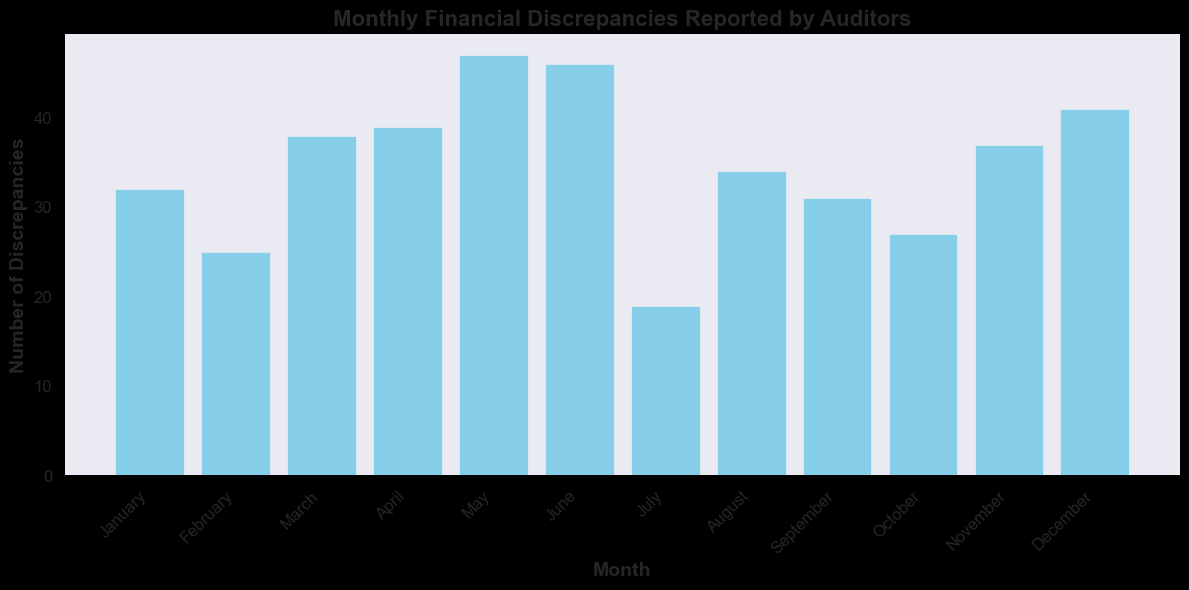What's the total number of discrepancies reported in March and April combined? First, find the number of discrepancies for March and April in the bar chart. For March, it's 38, and for April, it's 39. The total is 38 + 39 = 77.
Answer: 77 Which month has the highest number of discrepancies? Look for the highest bar in the bar chart. May has the tallest bar, indicating it has the highest number of discrepancies, which is 47.
Answer: May How many more discrepancies were reported in June compared to July? Check the values for June and July in the bar chart. June has 46 discrepancies, and July has 19 discrepancies. The difference is 46 - 19 = 27.
Answer: 27 In which month was the number of discrepancies the lowest? Identify the shortest bar in the chart. July has the shortest bar, indicating it has the lowest number of discrepancies, which is 19.
Answer: July What is the average number of discrepancies per month? Sum all discrepancies from each month and then divide by the number of months. January: 32, February: 25, March: 38, April: 39, May: 47, June: 46, July: 19, August: 34, September: 31, October: 27, November: 37, December: 41. Total is 416. Average = 416 / 12 ≈ 34.67.
Answer: 34.67 Which months have more than 40 discrepancies? Look at the bars that extend beyond the 40-mark on y-axis. May, June, and December have more than 40 discrepancies.
Answer: May, June, December Between which two consecutive months is the biggest increase in discrepancies reported? Compare the values between consecutive months and find the largest positive difference. April to May has an increase from 39 to 47, which is 8.
Answer: April to May By how much did the discrepancies reduce from May to July? Look at the discrepancies reported in May, June, and July. May has 47, June has 46, and July has 19. The reduction from May to July is 47 - 19 = 28.
Answer: 28 